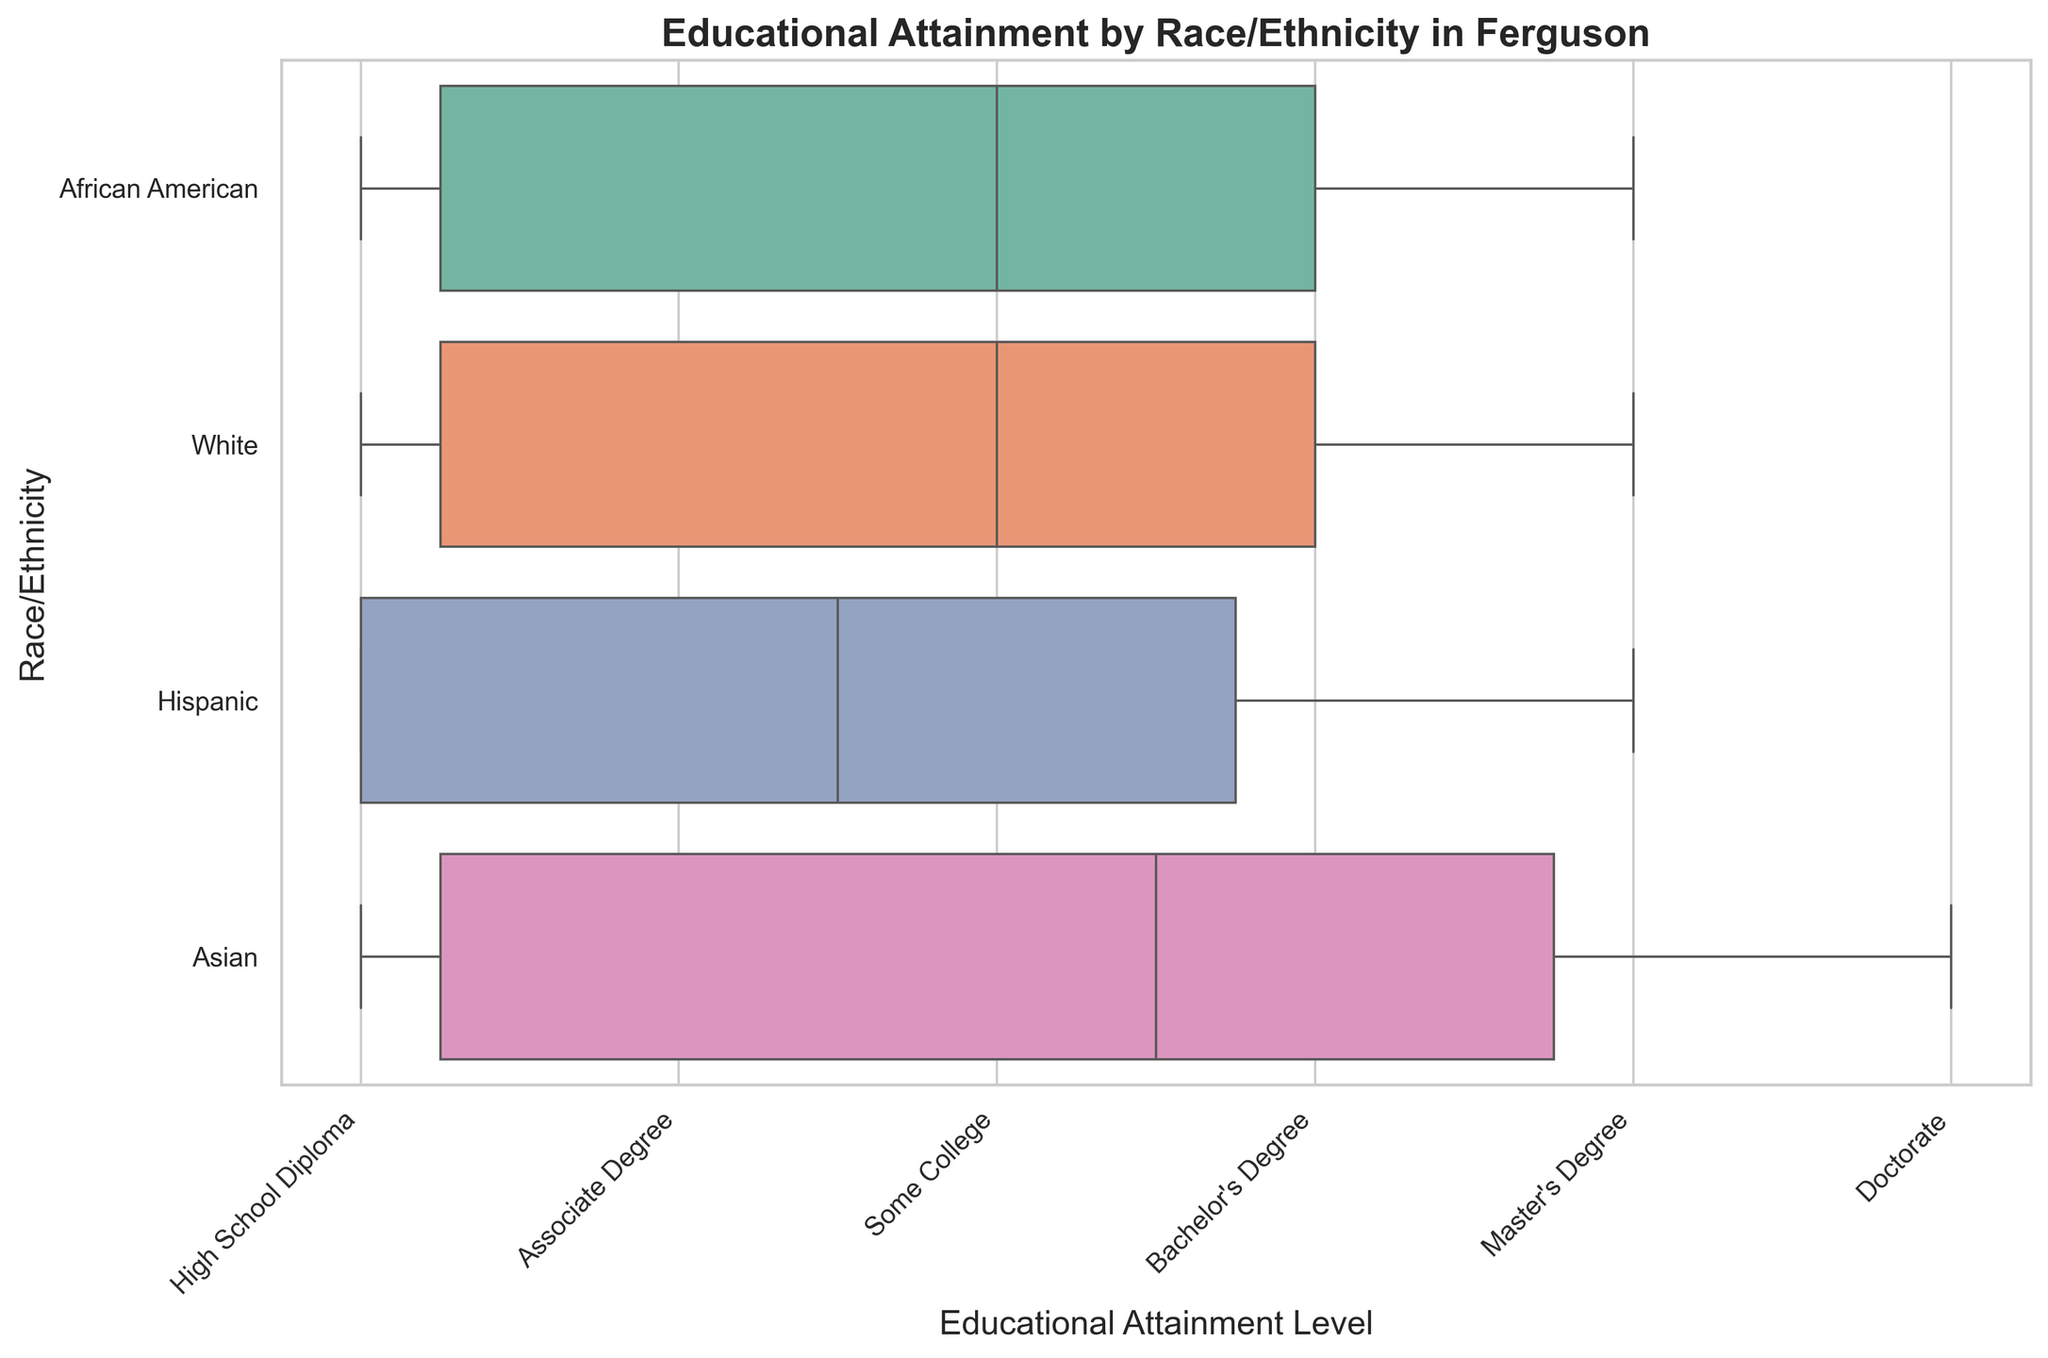Which racial or ethnic group has the highest median educational attainment level? According to the box plot, the Asian group has the highest median educational attainment level, which is around a Bachelor's Degree or higher.
Answer: Asian Which racial or ethnic group shows the most variation in educational attainment levels? By looking at the spread of the boxes and whiskers in the chart, the African American group shows the widest range of educational attainment levels, indicating the most variation.
Answer: African American Is there any racial or ethnic group that has members with a Doctorate degree? The box plot shows that only the Asian group has members who attained a Doctorate degree.
Answer: Asian Which racial or ethnic group has the lowest median educational attainment level? The Hispanic group has a median educational attainment level at or near a High School Diploma, making it the lowest among all groups shown in the plot.
Answer: Hispanic Which racial or ethnic groups have members with a Master's degree? The box plot illustrates that both African American and White groups include individuals with a Master's degree.
Answer: African American, White Which racial or ethnic group has the least variation in educational attainment levels? Looking at the box plot, the White group has the least variation, as indicated by the narrower spread of the box and whiskers.
Answer: White In terms of educational attainment, which group shows a higher concentration of lower-level degrees (High School Diploma or Associate Degree)? The Hispanic group shows a higher concentration of lower-level degrees such as High School Diploma and Associate Degree.
Answer: Hispanic Compare the educational attainment levels between the White and African American groups. Which group has a higher median attainment? The median educational attainment level for White individuals is higher than that of African American individuals, suggesting that White individuals generally attain higher education.
Answer: White Do all racial or ethnic groups have a similar upper range of educational attainment (Bachelor's degree or higher)? The box plot shows that not all groups reach the same upper range; while groups like Asian and White have higher representation in Bachelor's and higher degrees, Hispanic group has fewer representations.
Answer: No Which group has a higher median educational attainment level: African American or Hispanic? The box plot indicates that the African American group's median educational attainment level is higher than that of the Hispanic group.
Answer: African American 